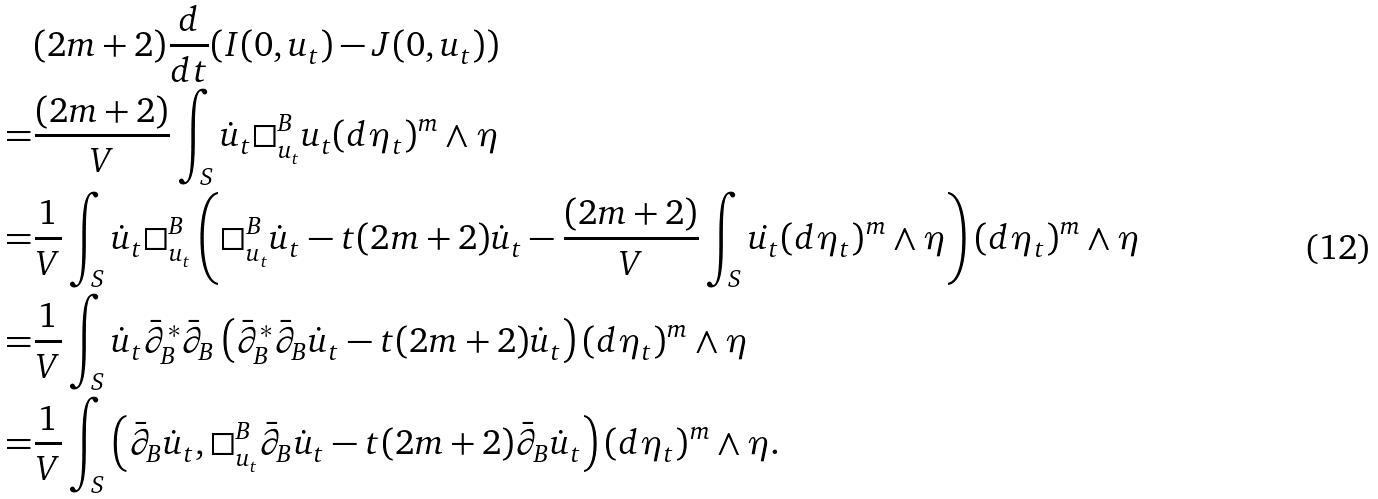Convert formula to latex. <formula><loc_0><loc_0><loc_500><loc_500>& ( 2 m + 2 ) \frac { d } { d t } ( I ( 0 , u _ { t } ) - J ( 0 , u _ { t } ) ) \\ = & \frac { ( 2 m + 2 ) } { V } \int _ { S } \dot { u } _ { t } \square _ { u _ { t } } ^ { B } u _ { t } ( d \eta _ { t } ) ^ { m } \wedge \eta \\ = & \frac { 1 } { V } \int _ { S } \dot { u } _ { t } \square _ { u _ { t } } ^ { B } \left ( \square ^ { B } _ { u _ { t } } \dot { u } _ { t } - t ( 2 m + 2 ) \dot { u } _ { t } - \frac { ( 2 m + 2 ) } { V } \int _ { S } \dot { u _ { t } } ( d \eta _ { t } ) ^ { m } \wedge \eta \right ) ( d \eta _ { t } ) ^ { m } \wedge \eta \\ = & \frac { 1 } { V } \int _ { S } \dot { u } _ { t } \bar { \partial } _ { B } ^ { * } \bar { \partial } _ { B } \left ( \bar { \partial } _ { B } ^ { * } \bar { \partial } _ { B } \dot { u } _ { t } - t ( 2 m + 2 ) \dot { u } _ { t } \right ) ( d \eta _ { t } ) ^ { m } \wedge \eta \\ = & \frac { 1 } { V } \int _ { S } \left ( \bar { \partial } _ { B } \dot { u } _ { t } , \square _ { u _ { t } } ^ { B } \bar { \partial } _ { B } \dot { u } _ { t } - t ( 2 m + 2 ) \bar { \partial } _ { B } \dot { u } _ { t } \right ) ( d \eta _ { t } ) ^ { m } \wedge \eta .</formula> 